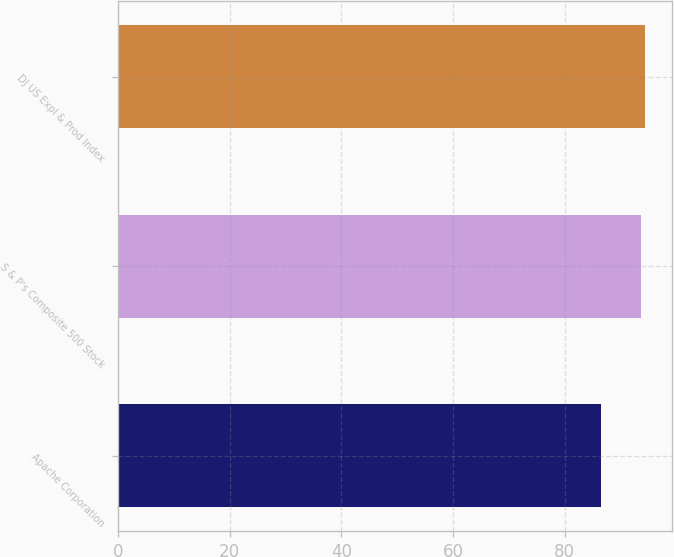Convert chart to OTSL. <chart><loc_0><loc_0><loc_500><loc_500><bar_chart><fcel>Apache Corporation<fcel>S & P's Composite 500 Stock<fcel>DJ US Expl & Prod Index<nl><fcel>86.43<fcel>93.61<fcel>94.38<nl></chart> 